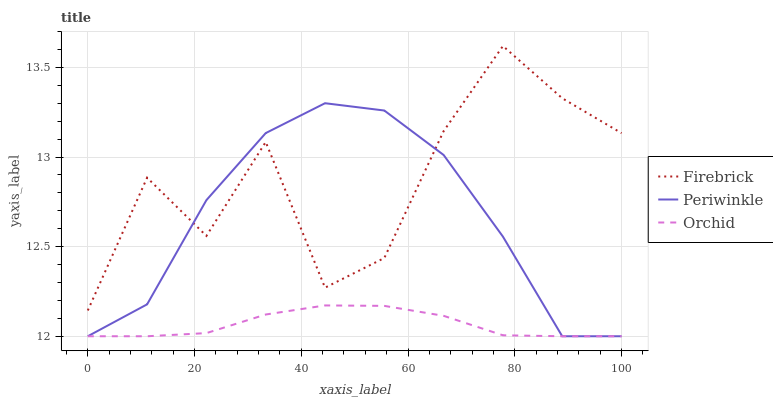Does Orchid have the minimum area under the curve?
Answer yes or no. Yes. Does Firebrick have the maximum area under the curve?
Answer yes or no. Yes. Does Periwinkle have the minimum area under the curve?
Answer yes or no. No. Does Periwinkle have the maximum area under the curve?
Answer yes or no. No. Is Orchid the smoothest?
Answer yes or no. Yes. Is Firebrick the roughest?
Answer yes or no. Yes. Is Periwinkle the smoothest?
Answer yes or no. No. Is Periwinkle the roughest?
Answer yes or no. No. Does Periwinkle have the lowest value?
Answer yes or no. Yes. Does Firebrick have the highest value?
Answer yes or no. Yes. Does Periwinkle have the highest value?
Answer yes or no. No. Is Orchid less than Firebrick?
Answer yes or no. Yes. Is Firebrick greater than Orchid?
Answer yes or no. Yes. Does Periwinkle intersect Firebrick?
Answer yes or no. Yes. Is Periwinkle less than Firebrick?
Answer yes or no. No. Is Periwinkle greater than Firebrick?
Answer yes or no. No. Does Orchid intersect Firebrick?
Answer yes or no. No. 